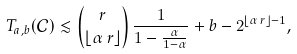<formula> <loc_0><loc_0><loc_500><loc_500>T _ { a , b } ( \mathcal { C } ) \lesssim \binom { r } { \lfloor \alpha \, r \rfloor } \, \frac { 1 } { 1 - \frac { \alpha } { 1 - \alpha } } + b - 2 ^ { \lfloor \alpha \, r \rfloor - 1 } ,</formula> 